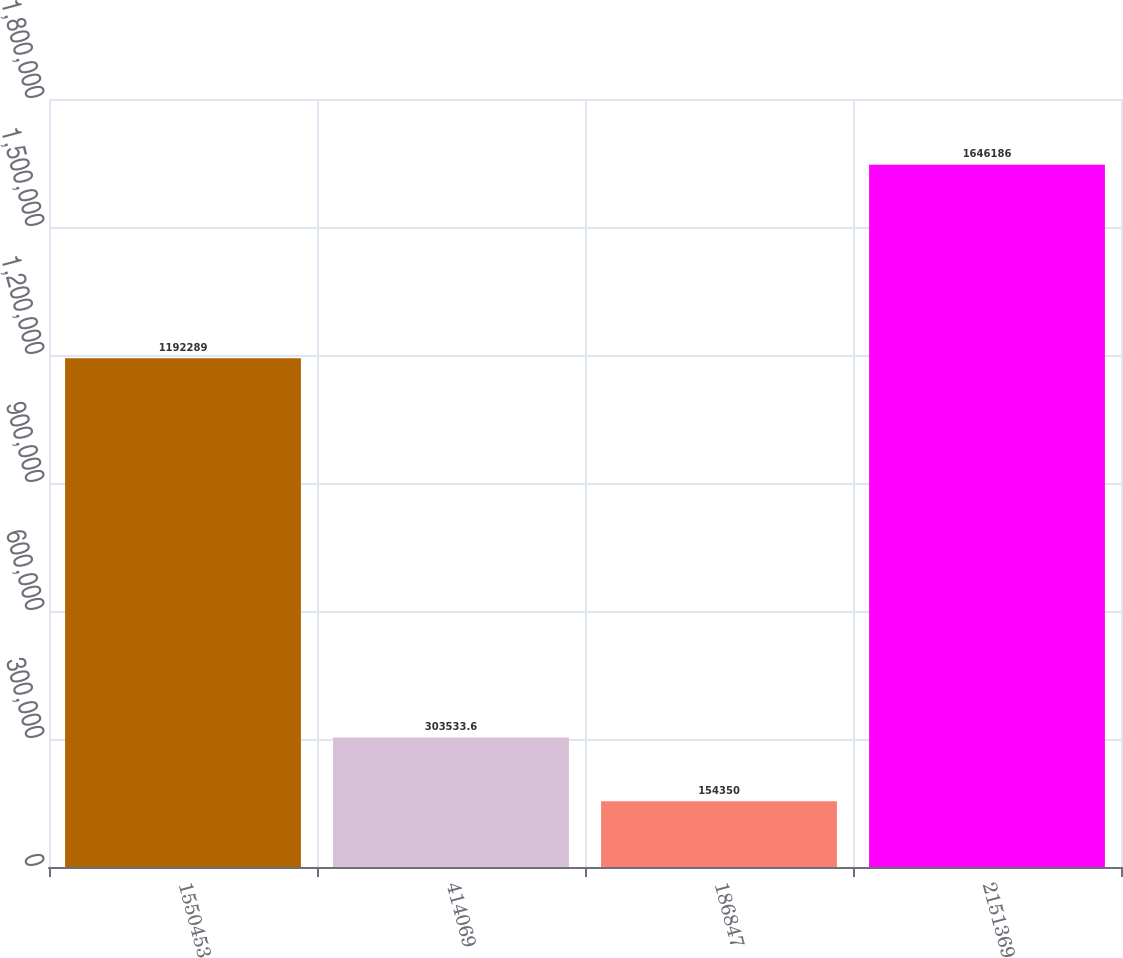<chart> <loc_0><loc_0><loc_500><loc_500><bar_chart><fcel>1550453<fcel>414069<fcel>186847<fcel>2151369<nl><fcel>1.19229e+06<fcel>303534<fcel>154350<fcel>1.64619e+06<nl></chart> 